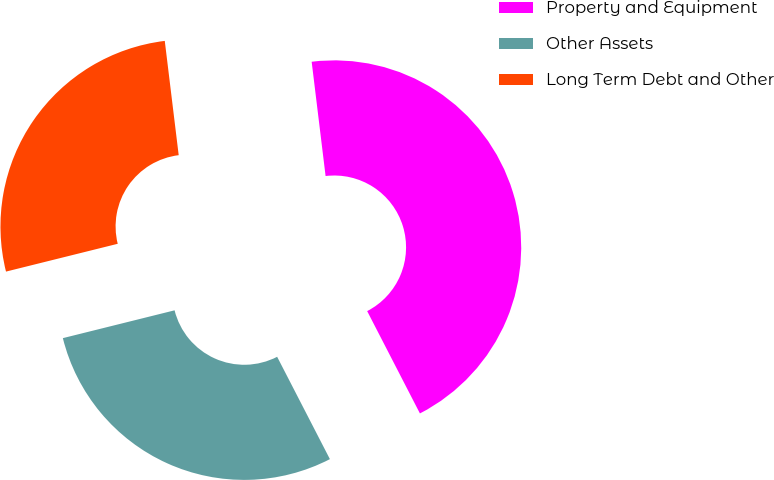Convert chart. <chart><loc_0><loc_0><loc_500><loc_500><pie_chart><fcel>Property and Equipment<fcel>Other Assets<fcel>Long Term Debt and Other<nl><fcel>44.35%<fcel>28.69%<fcel>26.95%<nl></chart> 